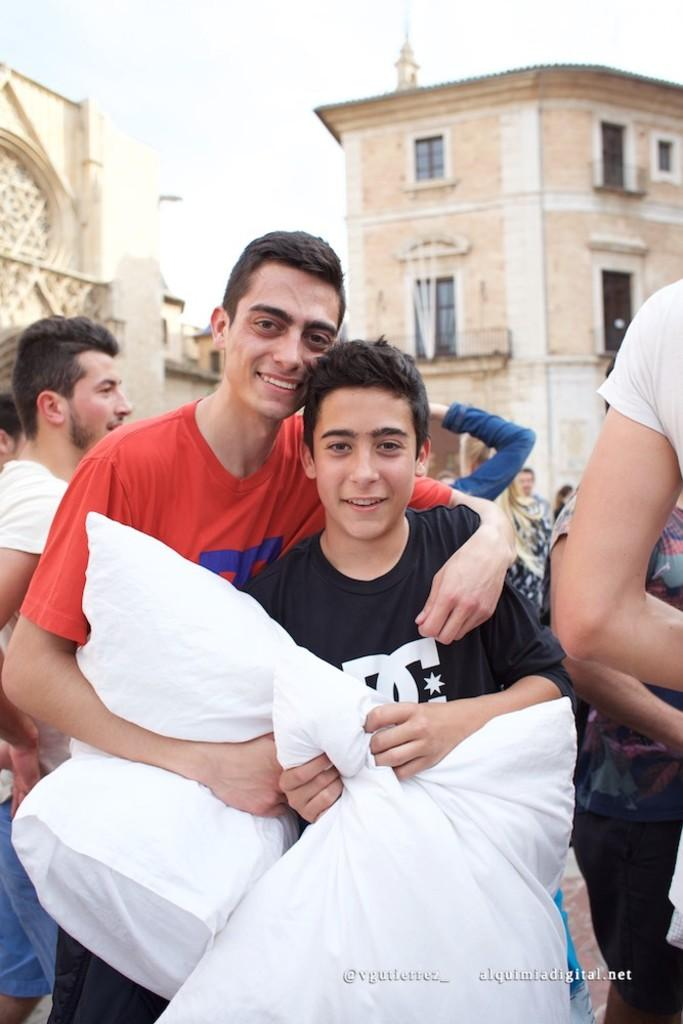How many people are present in the image? There are two people standing in the image. What are the people holding in their hands? The people are holding white objects. What can be seen in the background of the image? There are buildings, windows, and people visible in the background. What is the color of the sky in the image? The sky is blue and white in color. How many mint leaves can be seen on the people's heads in the image? There are no mint leaves visible on the people's heads in the image. Can you tell me the value of the sheep in the image? There are no sheep present in the image, so it is not possible to determine their value. 